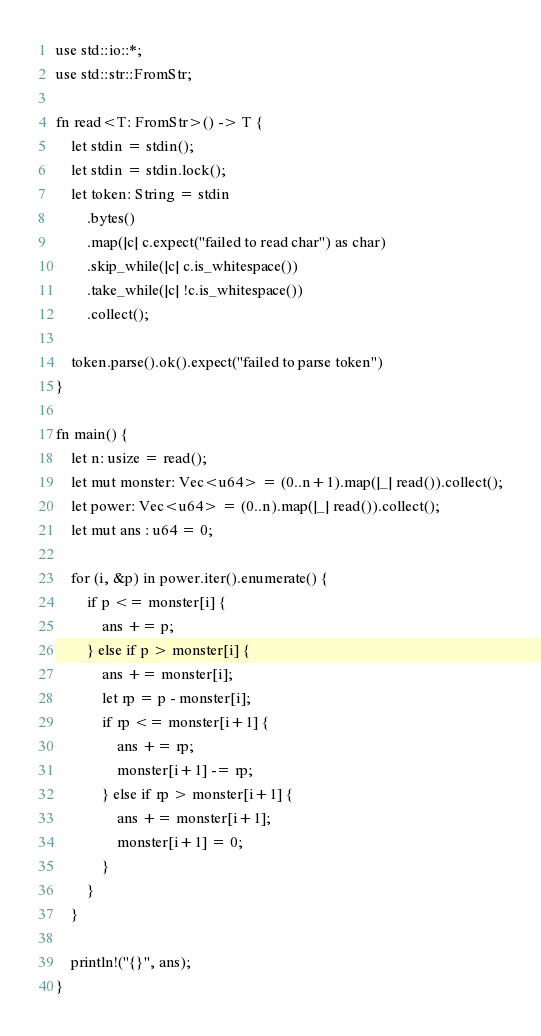<code> <loc_0><loc_0><loc_500><loc_500><_Rust_>use std::io::*;
use std::str::FromStr;

fn read<T: FromStr>() -> T {
    let stdin = stdin();
    let stdin = stdin.lock();
    let token: String = stdin
        .bytes()
        .map(|c| c.expect("failed to read char") as char)
        .skip_while(|c| c.is_whitespace())
        .take_while(|c| !c.is_whitespace())
        .collect();

    token.parse().ok().expect("failed to parse token")
}

fn main() {
    let n: usize = read();
    let mut monster: Vec<u64> = (0..n+1).map(|_| read()).collect();
    let power: Vec<u64> = (0..n).map(|_| read()).collect();
    let mut ans : u64 = 0;

    for (i, &p) in power.iter().enumerate() {
        if p <= monster[i] {
            ans += p;
        } else if p > monster[i] {
            ans += monster[i];
            let rp = p - monster[i];
            if rp <= monster[i+1] {
                ans += rp;
                monster[i+1] -= rp;
            } else if rp > monster[i+1] {
                ans += monster[i+1];
                monster[i+1] = 0;
            }
        }
    }

    println!("{}", ans);
}
</code> 